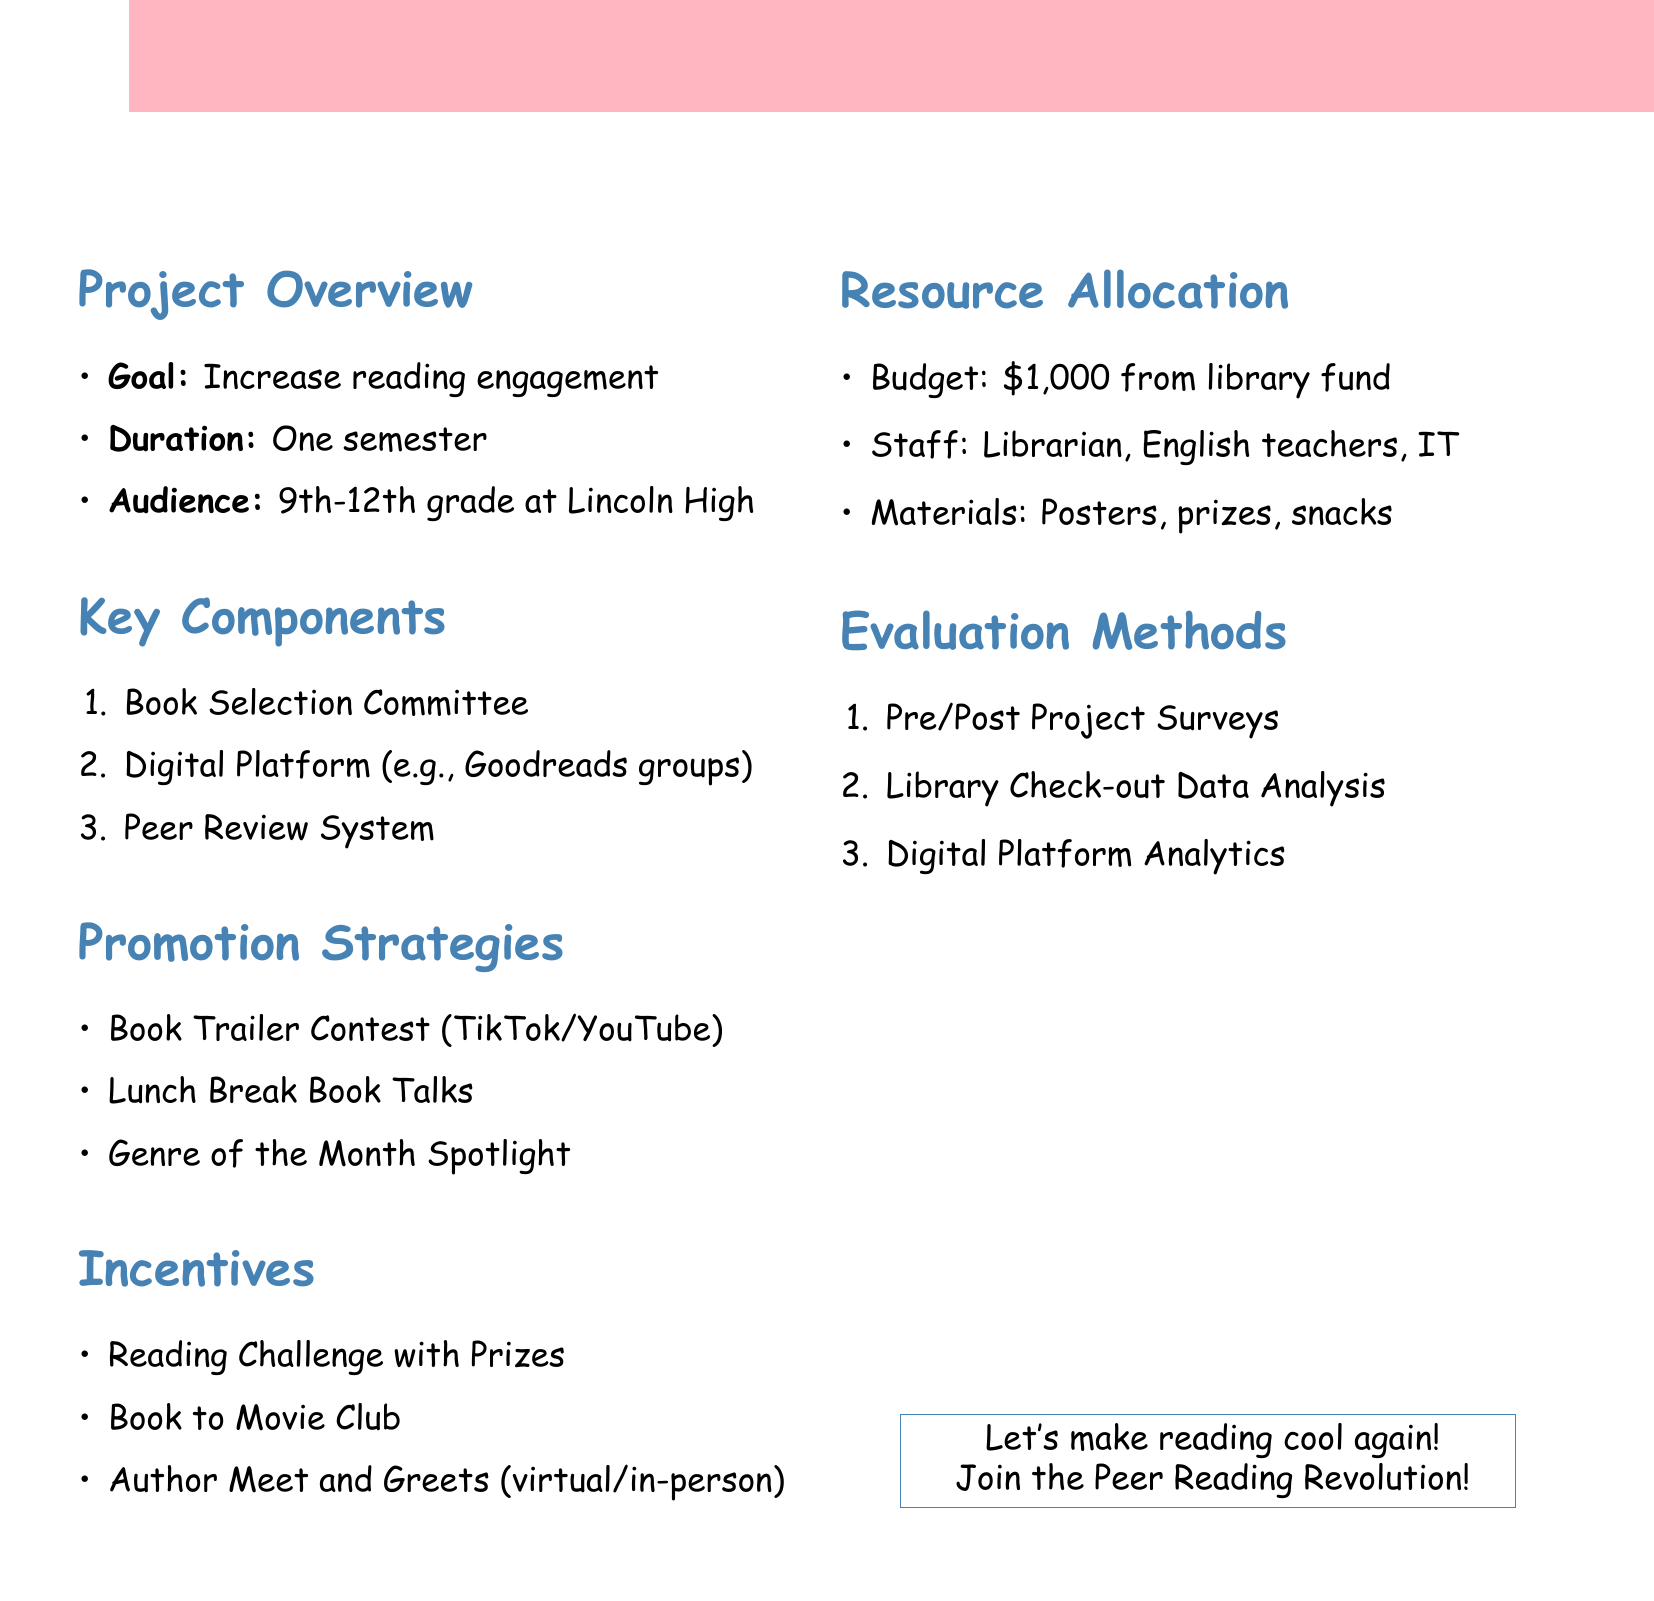what is the title of the project? The title of the project is stated in the project overview section.
Answer: Peer Reading Revolution how long is the project expected to last? The duration of the project is mentioned in the overview section.
Answer: One semester what is the total budget allocated for this project? The budget for the project is listed under resource allocation.
Answer: $1,000 which high school grades are targeted for the project? The target audience is specified in the project overview section.
Answer: 9th to 12th grade which digital platform options are suggested for sharing recommendations? The document lists options under the digital platform component.
Answer: Goodreads groups, Custom school website, Instagram book review account what type of contest is mentioned to promote reading? The promotion strategies section describes an event to engage students.
Answer: Book Trailer Contest name one potential author for the Meet and Greets event. The document provides examples of authors that could potentially be invited.
Answer: John Green what method will be used to evaluate changes in reading habits? Evaluation methods describe a way to assess reading engagement.
Answer: Survey how are students incentivized in this project? The incentives section lists different ways to encourage participation.
Answer: Reading Challenge with Prizes 